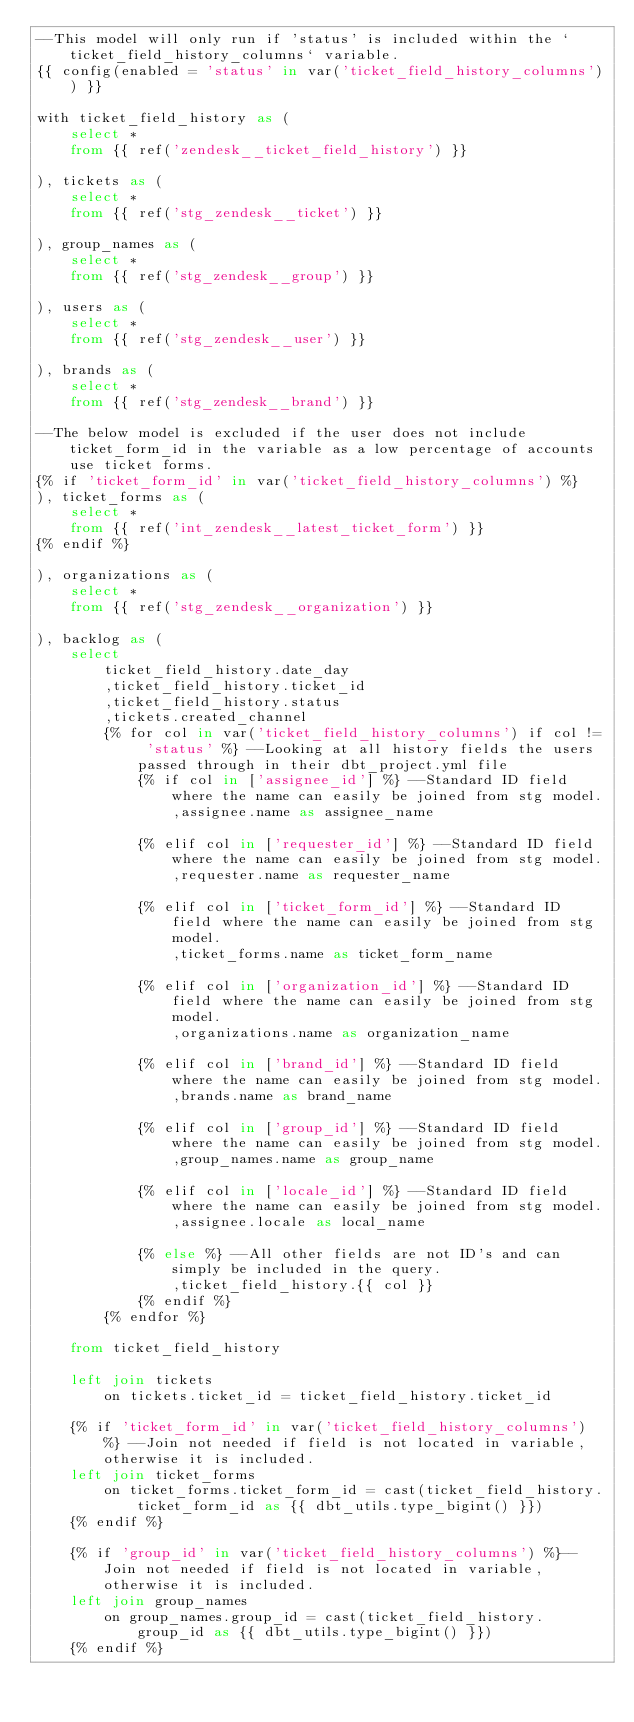Convert code to text. <code><loc_0><loc_0><loc_500><loc_500><_SQL_>--This model will only run if 'status' is included within the `ticket_field_history_columns` variable.
{{ config(enabled = 'status' in var('ticket_field_history_columns')) }}

with ticket_field_history as (
    select *
    from {{ ref('zendesk__ticket_field_history') }}

), tickets as (
    select *
    from {{ ref('stg_zendesk__ticket') }}

), group_names as (
    select *
    from {{ ref('stg_zendesk__group') }}

), users as (
    select *
    from {{ ref('stg_zendesk__user') }}

), brands as (
    select *
    from {{ ref('stg_zendesk__brand') }}

--The below model is excluded if the user does not include ticket_form_id in the variable as a low percentage of accounts use ticket forms.
{% if 'ticket_form_id' in var('ticket_field_history_columns') %}
), ticket_forms as (
    select *
    from {{ ref('int_zendesk__latest_ticket_form') }}
{% endif %}

), organizations as (
    select *
    from {{ ref('stg_zendesk__organization') }}

), backlog as (
    select
        ticket_field_history.date_day
        ,ticket_field_history.ticket_id
        ,ticket_field_history.status
        ,tickets.created_channel
        {% for col in var('ticket_field_history_columns') if col != 'status' %} --Looking at all history fields the users passed through in their dbt_project.yml file
            {% if col in ['assignee_id'] %} --Standard ID field where the name can easily be joined from stg model.
                ,assignee.name as assignee_name

            {% elif col in ['requester_id'] %} --Standard ID field where the name can easily be joined from stg model.
                ,requester.name as requester_name

            {% elif col in ['ticket_form_id'] %} --Standard ID field where the name can easily be joined from stg model.
                ,ticket_forms.name as ticket_form_name

            {% elif col in ['organization_id'] %} --Standard ID field where the name can easily be joined from stg model.
                ,organizations.name as organization_name

            {% elif col in ['brand_id'] %} --Standard ID field where the name can easily be joined from stg model.
                ,brands.name as brand_name

            {% elif col in ['group_id'] %} --Standard ID field where the name can easily be joined from stg model.
                ,group_names.name as group_name

            {% elif col in ['locale_id'] %} --Standard ID field where the name can easily be joined from stg model.
                ,assignee.locale as local_name

            {% else %} --All other fields are not ID's and can simply be included in the query.
                ,ticket_field_history.{{ col }}
            {% endif %}
        {% endfor %}

    from ticket_field_history

    left join tickets
        on tickets.ticket_id = ticket_field_history.ticket_id

    {% if 'ticket_form_id' in var('ticket_field_history_columns') %} --Join not needed if field is not located in variable, otherwise it is included.
    left join ticket_forms
        on ticket_forms.ticket_form_id = cast(ticket_field_history.ticket_form_id as {{ dbt_utils.type_bigint() }})
    {% endif %}

    {% if 'group_id' in var('ticket_field_history_columns') %}--Join not needed if field is not located in variable, otherwise it is included.
    left join group_names
        on group_names.group_id = cast(ticket_field_history.group_id as {{ dbt_utils.type_bigint() }})
    {% endif %}
</code> 